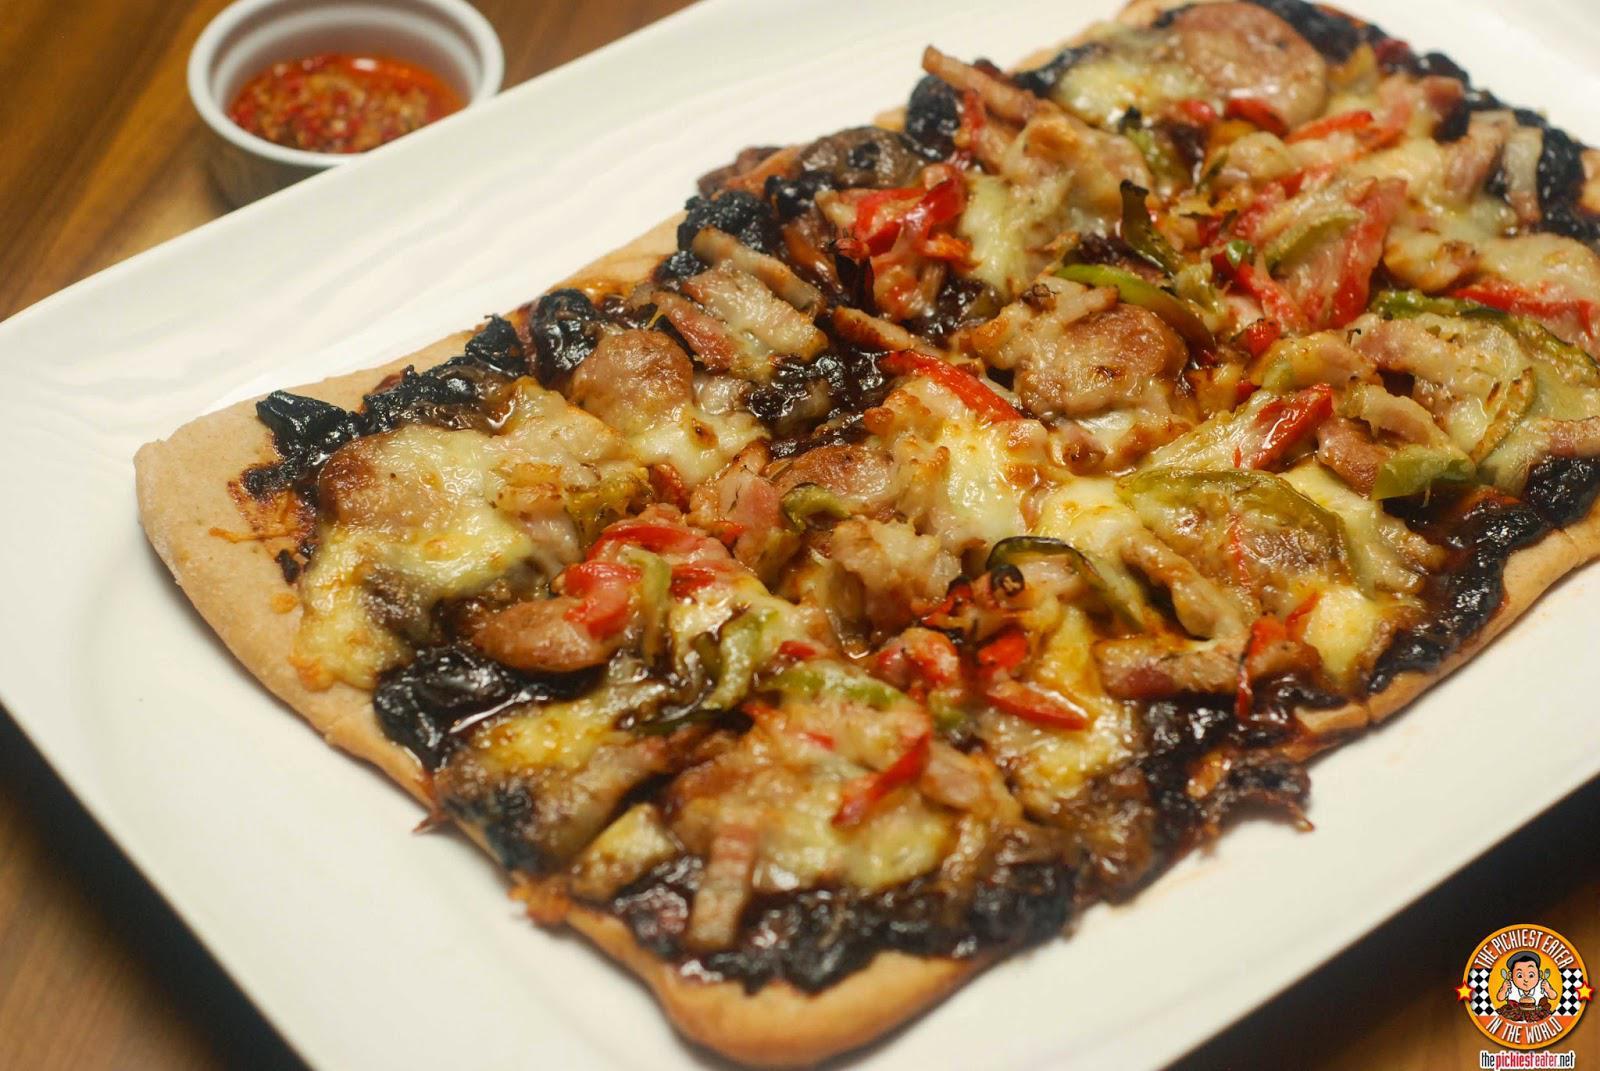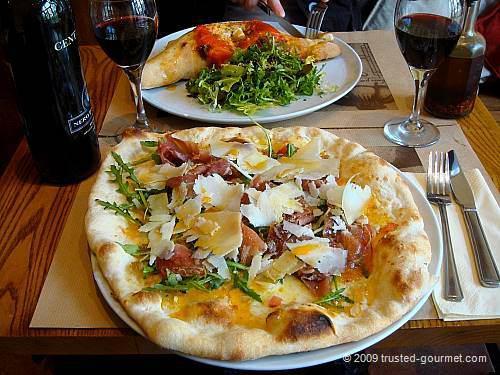The first image is the image on the left, the second image is the image on the right. Considering the images on both sides, is "Part of a pizza is missing." valid? Answer yes or no. No. The first image is the image on the left, the second image is the image on the right. Given the left and right images, does the statement "The left image includes at least two round platters of food and at least one small condiment cup next to a sliced pizza on a brown plank surface." hold true? Answer yes or no. No. 